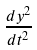<formula> <loc_0><loc_0><loc_500><loc_500>\frac { d y ^ { 2 } } { d t ^ { 2 } }</formula> 